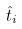<formula> <loc_0><loc_0><loc_500><loc_500>\hat { t } _ { i }</formula> 